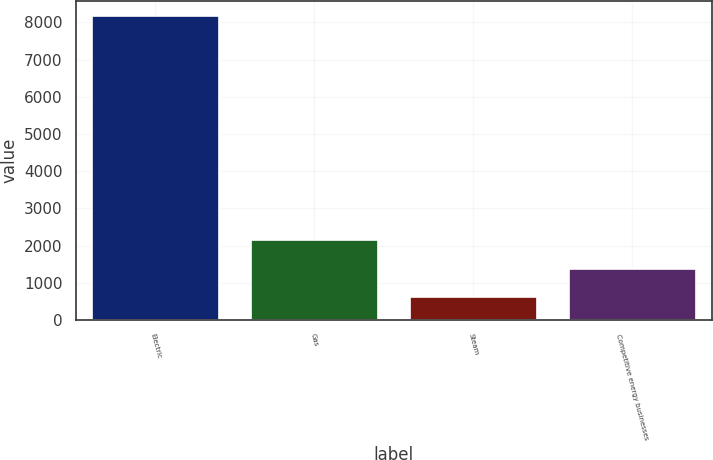<chart> <loc_0><loc_0><loc_500><loc_500><bar_chart><fcel>Electric<fcel>Gas<fcel>Steam<fcel>Competitive energy businesses<nl><fcel>8172<fcel>2137.6<fcel>629<fcel>1383.3<nl></chart> 